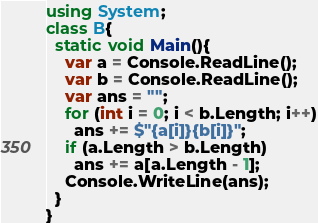Convert code to text. <code><loc_0><loc_0><loc_500><loc_500><_C#_>using System;
class B{
  static void Main(){
    var a = Console.ReadLine();
    var b = Console.ReadLine();
    var ans = "";
    for (int i = 0; i < b.Length; i++)
      ans += $"{a[i]}{b[i]}";
    if (a.Length > b.Length)
      ans += a[a.Length - 1];
    Console.WriteLine(ans);
  }
}</code> 